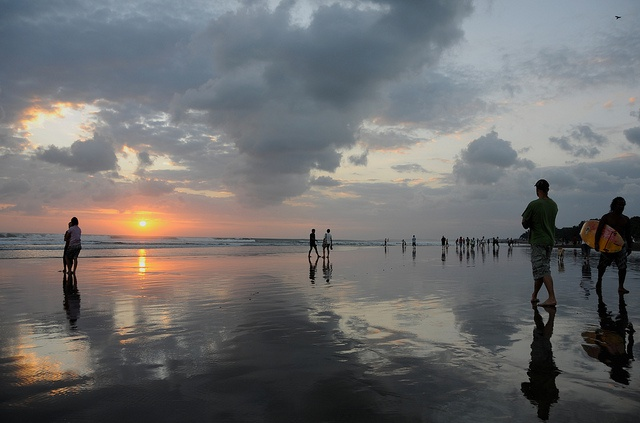Describe the objects in this image and their specific colors. I can see people in gray and black tones, people in gray, black, purple, and maroon tones, people in gray and black tones, surfboard in gray, maroon, and black tones, and people in gray and black tones in this image. 